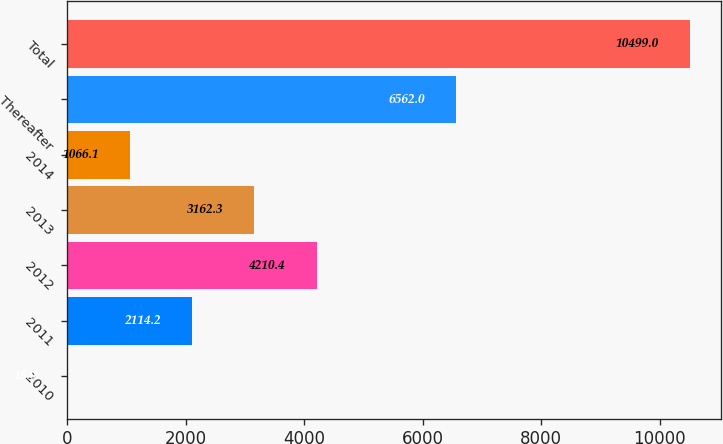Convert chart. <chart><loc_0><loc_0><loc_500><loc_500><bar_chart><fcel>2010<fcel>2011<fcel>2012<fcel>2013<fcel>2014<fcel>Thereafter<fcel>Total<nl><fcel>18<fcel>2114.2<fcel>4210.4<fcel>3162.3<fcel>1066.1<fcel>6562<fcel>10499<nl></chart> 